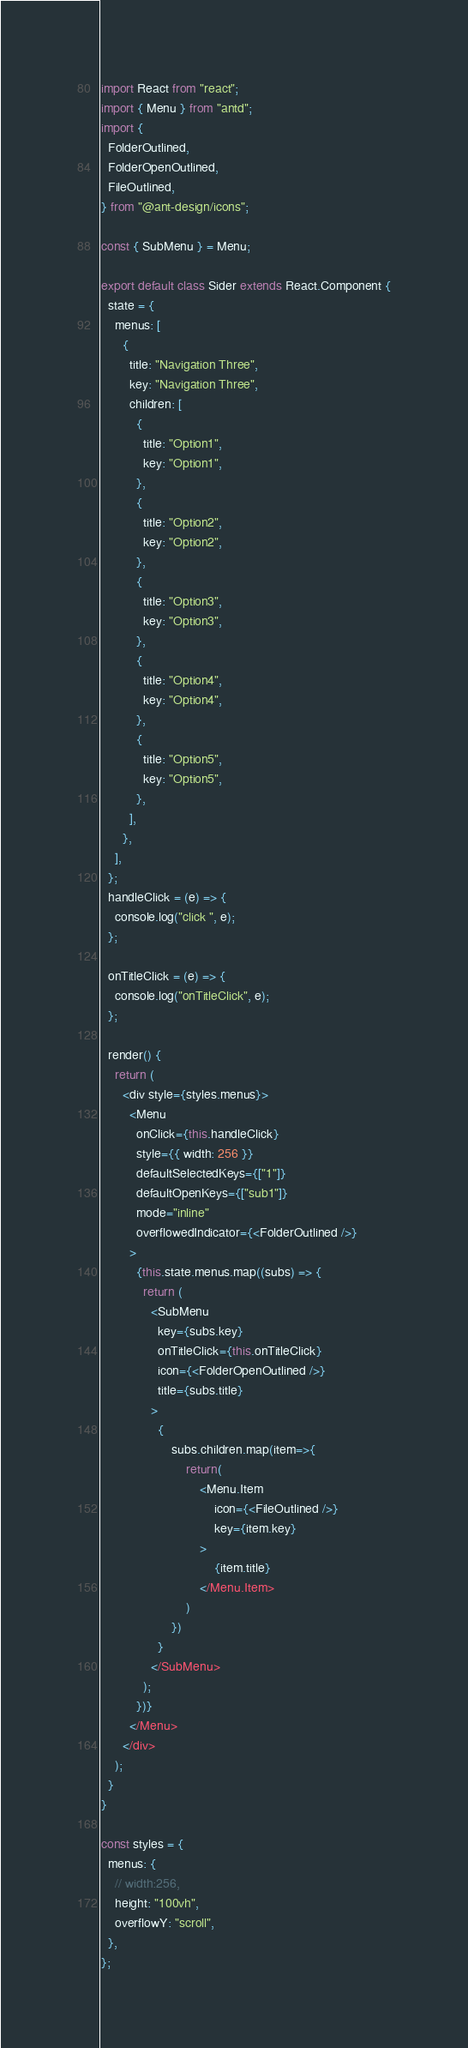Convert code to text. <code><loc_0><loc_0><loc_500><loc_500><_JavaScript_>import React from "react";
import { Menu } from "antd";
import {
  FolderOutlined,
  FolderOpenOutlined,
  FileOutlined,
} from "@ant-design/icons";

const { SubMenu } = Menu;

export default class Sider extends React.Component {
  state = {
    menus: [
      {
        title: "Navigation Three",
        key: "Navigation Three",
        children: [
          {
            title: "Option1",
            key: "Option1",
          },
          {
            title: "Option2",
            key: "Option2",
          },
          {
            title: "Option3",
            key: "Option3",
          },
          {
            title: "Option4",
            key: "Option4",
          },
          {
            title: "Option5",
            key: "Option5",
          },
        ],
      },
    ],
  };
  handleClick = (e) => {
    console.log("click ", e);
  };

  onTitleClick = (e) => {
    console.log("onTitleClick", e);
  };

  render() {
    return (
      <div style={styles.menus}>
        <Menu
          onClick={this.handleClick}
          style={{ width: 256 }}
          defaultSelectedKeys={["1"]}
          defaultOpenKeys={["sub1"]}
          mode="inline"
          overflowedIndicator={<FolderOutlined />}
        >
          {this.state.menus.map((subs) => {
            return (
              <SubMenu
                key={subs.key}
                onTitleClick={this.onTitleClick}
                icon={<FolderOpenOutlined />}
                title={subs.title}
              >
                {
                    subs.children.map(item=>{
                        return(
                            <Menu.Item 
                                icon={<FileOutlined />} 
                                key={item.key}
                            >
                                {item.title}
                            </Menu.Item>
                        )
                    })
                }
              </SubMenu>
            );
          })}
        </Menu>
      </div>
    );
  }
}

const styles = {
  menus: {
    // width:256,
    height: "100vh",
    overflowY: "scroll",
  },
};
</code> 